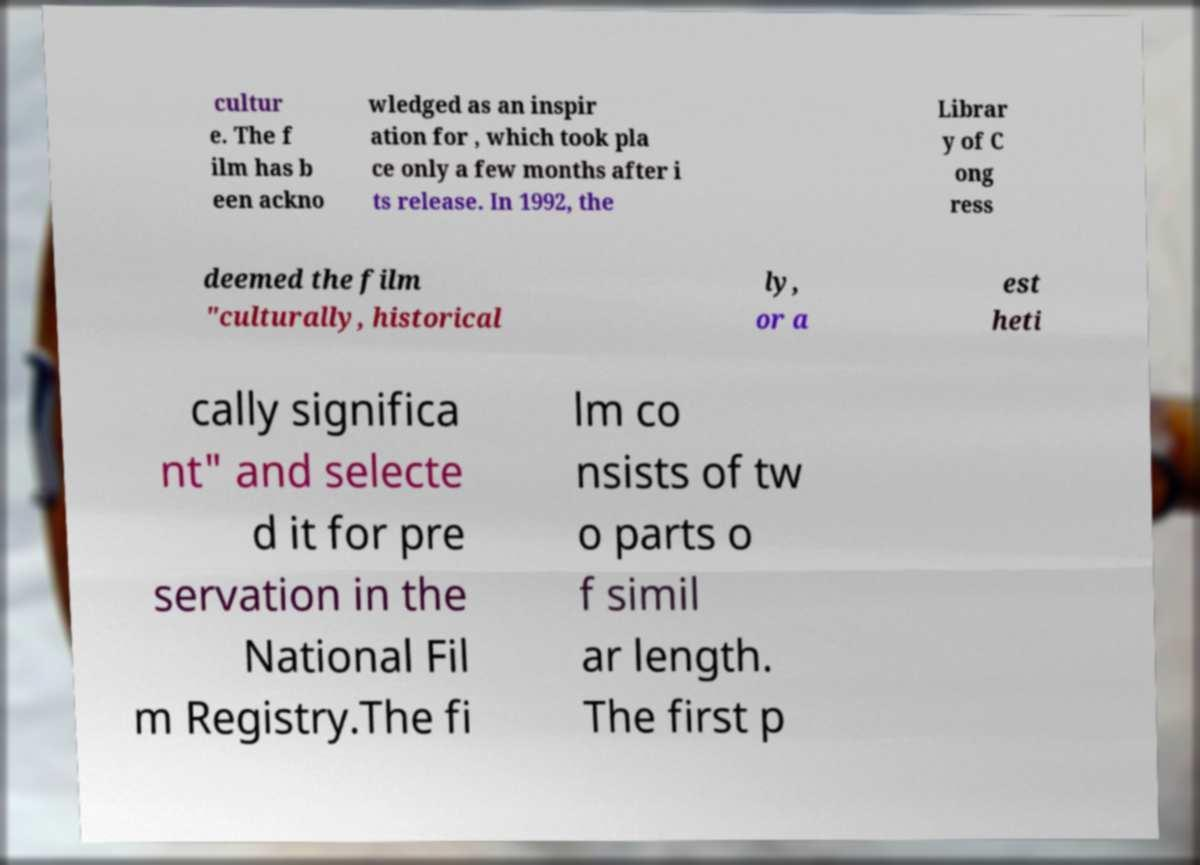Could you extract and type out the text from this image? cultur e. The f ilm has b een ackno wledged as an inspir ation for , which took pla ce only a few months after i ts release. In 1992, the Librar y of C ong ress deemed the film "culturally, historical ly, or a est heti cally significa nt" and selecte d it for pre servation in the National Fil m Registry.The fi lm co nsists of tw o parts o f simil ar length. The first p 